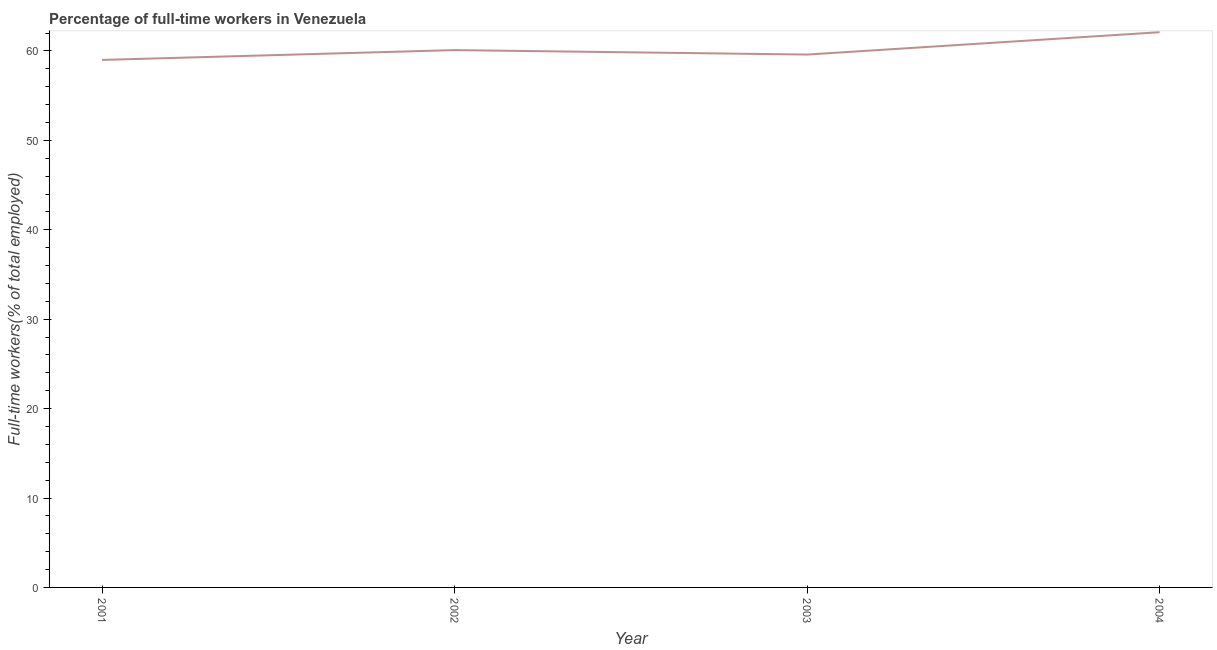Across all years, what is the maximum percentage of full-time workers?
Ensure brevity in your answer.  62.1. In which year was the percentage of full-time workers minimum?
Give a very brief answer. 2001. What is the sum of the percentage of full-time workers?
Keep it short and to the point. 240.8. What is the difference between the percentage of full-time workers in 2001 and 2004?
Offer a terse response. -3.1. What is the average percentage of full-time workers per year?
Offer a terse response. 60.2. What is the median percentage of full-time workers?
Give a very brief answer. 59.85. Do a majority of the years between 2001 and 2004 (inclusive) have percentage of full-time workers greater than 54 %?
Your response must be concise. Yes. What is the ratio of the percentage of full-time workers in 2002 to that in 2004?
Make the answer very short. 0.97. Is the percentage of full-time workers in 2002 less than that in 2003?
Provide a succinct answer. No. What is the difference between the highest and the second highest percentage of full-time workers?
Make the answer very short. 2. Is the sum of the percentage of full-time workers in 2002 and 2003 greater than the maximum percentage of full-time workers across all years?
Ensure brevity in your answer.  Yes. What is the difference between the highest and the lowest percentage of full-time workers?
Provide a succinct answer. 3.1. How many lines are there?
Provide a short and direct response. 1. Are the values on the major ticks of Y-axis written in scientific E-notation?
Offer a very short reply. No. Does the graph contain any zero values?
Keep it short and to the point. No. Does the graph contain grids?
Make the answer very short. No. What is the title of the graph?
Ensure brevity in your answer.  Percentage of full-time workers in Venezuela. What is the label or title of the Y-axis?
Provide a short and direct response. Full-time workers(% of total employed). What is the Full-time workers(% of total employed) in 2001?
Offer a terse response. 59. What is the Full-time workers(% of total employed) of 2002?
Offer a very short reply. 60.1. What is the Full-time workers(% of total employed) in 2003?
Ensure brevity in your answer.  59.6. What is the Full-time workers(% of total employed) in 2004?
Provide a succinct answer. 62.1. What is the difference between the Full-time workers(% of total employed) in 2001 and 2002?
Ensure brevity in your answer.  -1.1. What is the difference between the Full-time workers(% of total employed) in 2001 and 2004?
Provide a short and direct response. -3.1. What is the difference between the Full-time workers(% of total employed) in 2003 and 2004?
Make the answer very short. -2.5. What is the ratio of the Full-time workers(% of total employed) in 2001 to that in 2002?
Your response must be concise. 0.98. What is the ratio of the Full-time workers(% of total employed) in 2001 to that in 2004?
Give a very brief answer. 0.95. What is the ratio of the Full-time workers(% of total employed) in 2002 to that in 2003?
Make the answer very short. 1.01. What is the ratio of the Full-time workers(% of total employed) in 2002 to that in 2004?
Your answer should be very brief. 0.97. What is the ratio of the Full-time workers(% of total employed) in 2003 to that in 2004?
Provide a short and direct response. 0.96. 